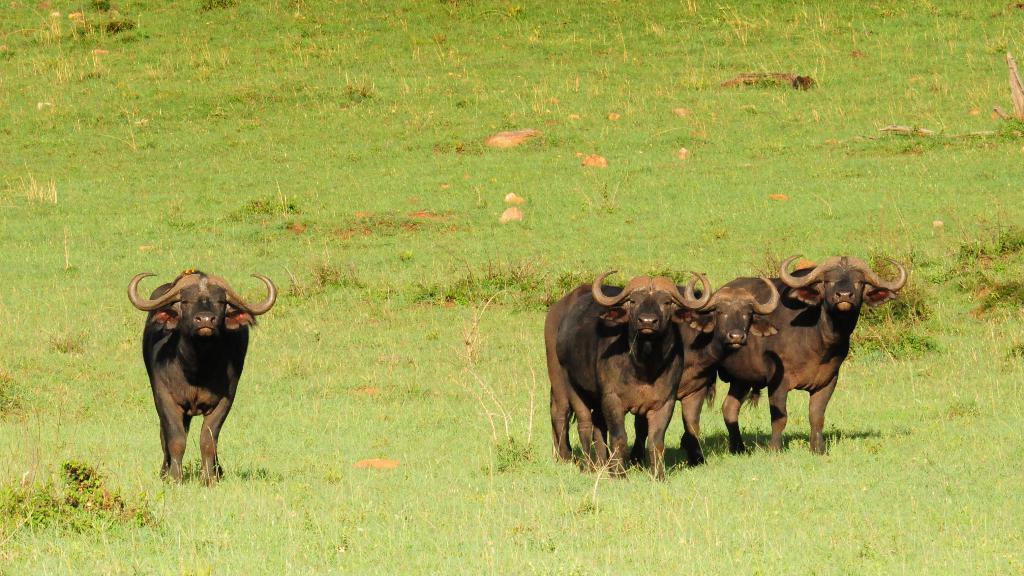Could you give a brief overview of what you see in this image? As we can see in the image there are black color bulls and there is grass. 